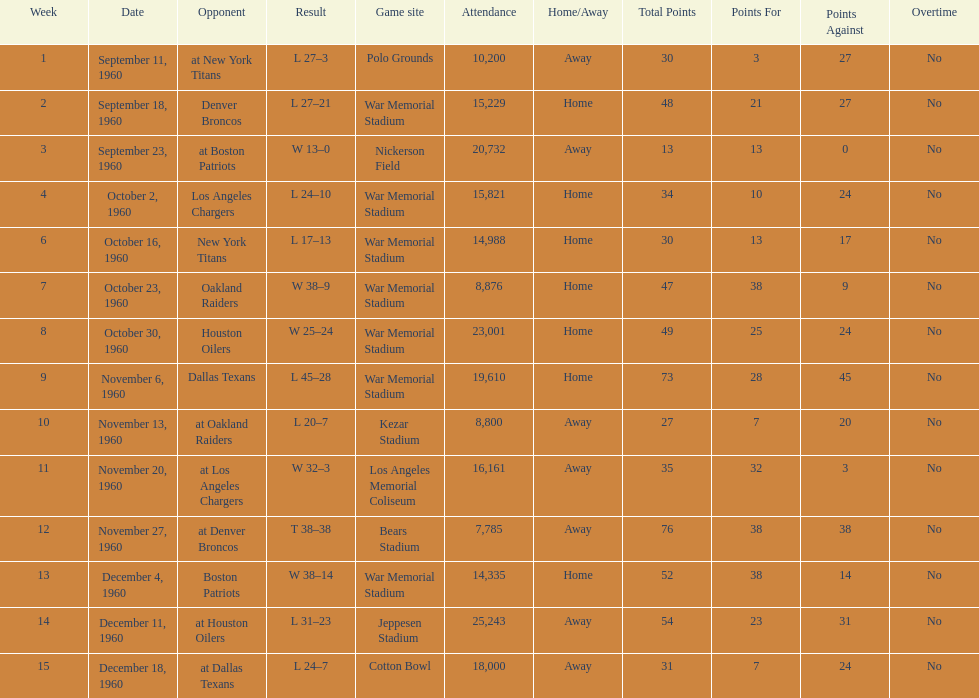What were the total number of games played in november? 4. 